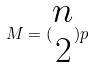Convert formula to latex. <formula><loc_0><loc_0><loc_500><loc_500>M = ( \begin{matrix} n \\ 2 \end{matrix} ) p</formula> 